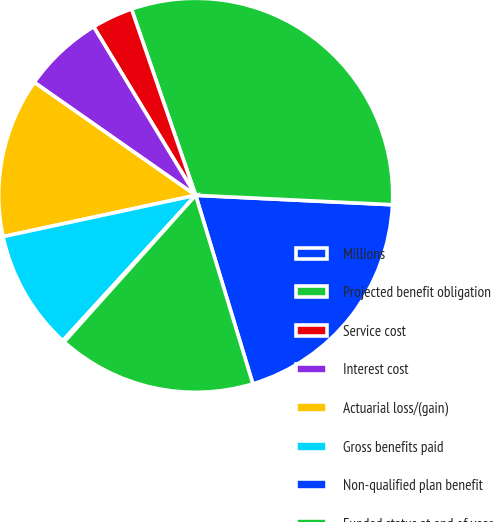Convert chart to OTSL. <chart><loc_0><loc_0><loc_500><loc_500><pie_chart><fcel>Millions<fcel>Projected benefit obligation<fcel>Service cost<fcel>Interest cost<fcel>Actuarial loss/(gain)<fcel>Gross benefits paid<fcel>Non-qualified plan benefit<fcel>Funded status at end of year<nl><fcel>19.55%<fcel>31.04%<fcel>3.38%<fcel>6.62%<fcel>13.08%<fcel>9.85%<fcel>0.15%<fcel>16.32%<nl></chart> 